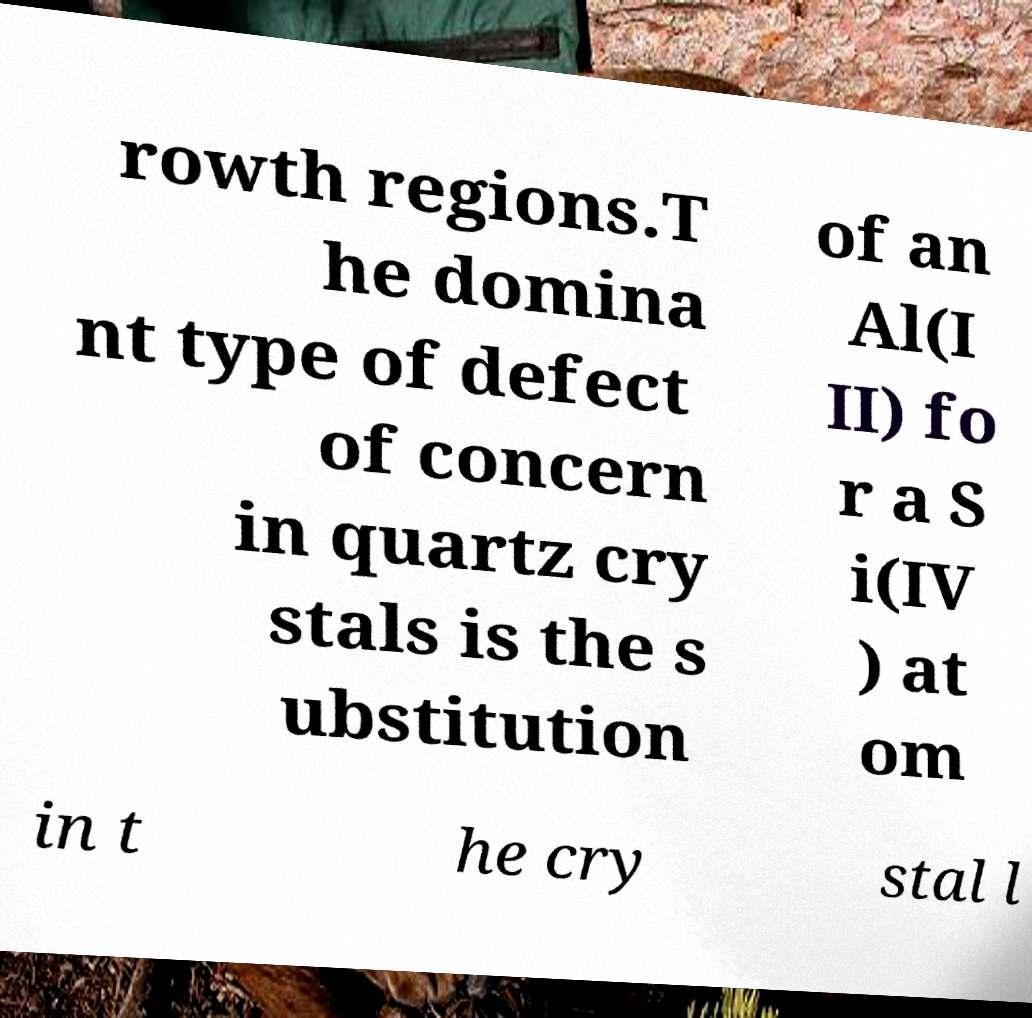Please read and relay the text visible in this image. What does it say? rowth regions.T he domina nt type of defect of concern in quartz cry stals is the s ubstitution of an Al(I II) fo r a S i(IV ) at om in t he cry stal l 